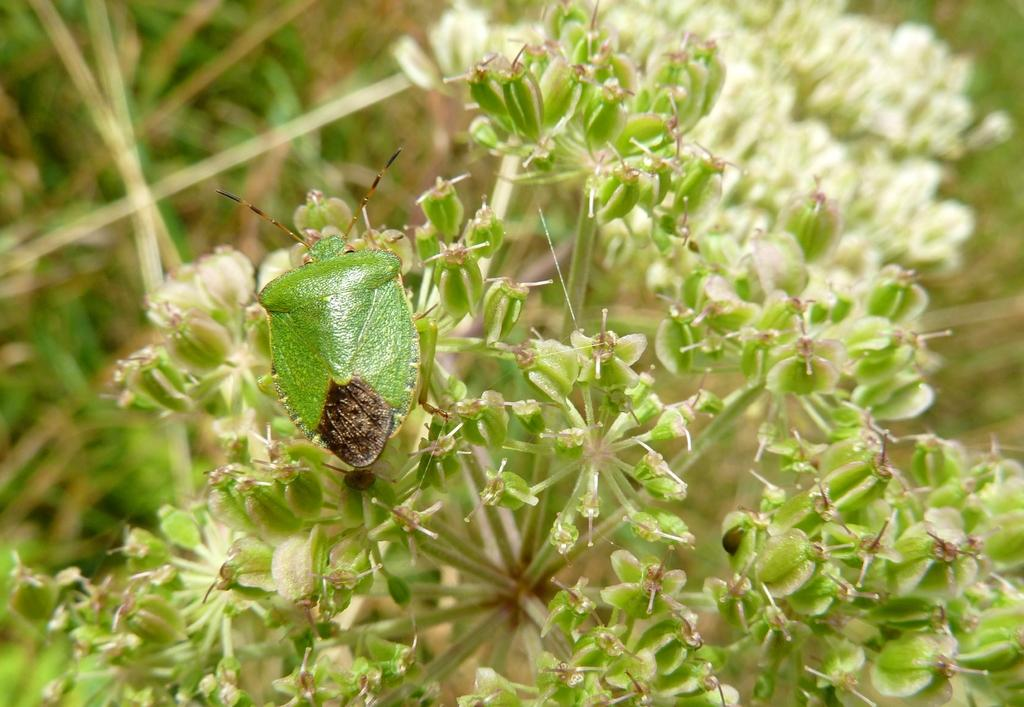What is present in the picture? There is a plant in the picture. Can you describe the insect in the image? There is an insect on the leaves of the plant. What can be observed about the background of the image? The background of the image is blurred or indistinct. How far away is the girl from the plant in the image? There is no girl present in the image, so it is not possible to determine the distance between a girl and the plant. 